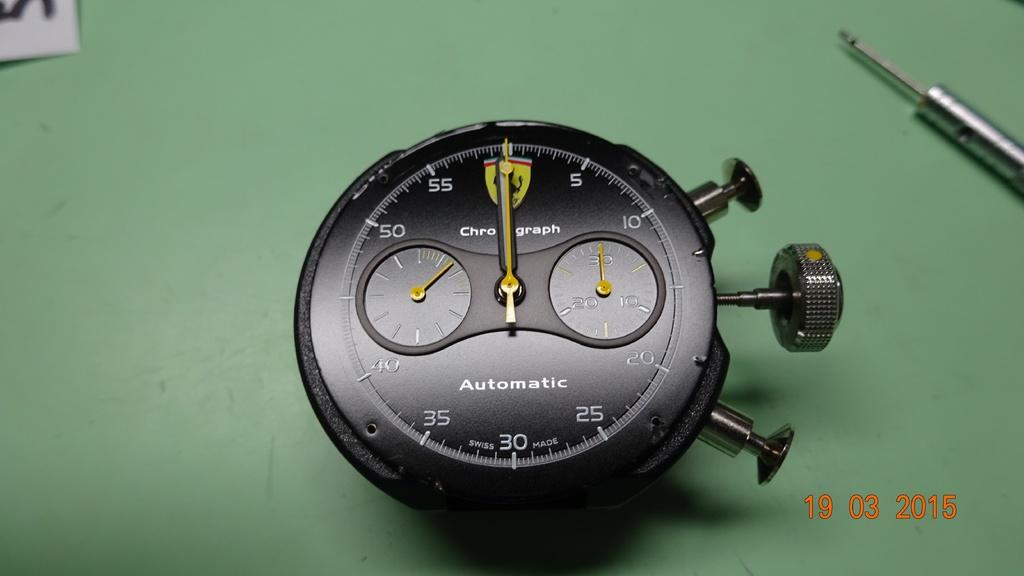<image>
Describe the image concisely. A chronograph automatic watch sits on a green table. 